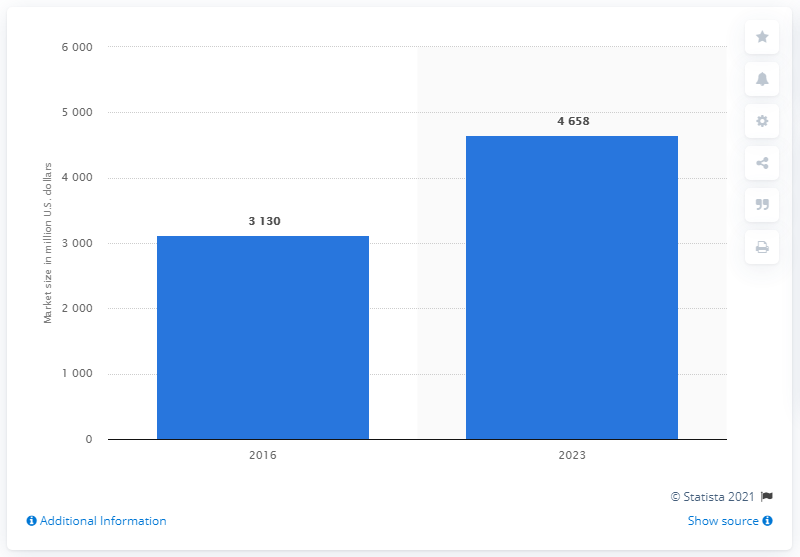Could you provide more context about the source of this data? The chart indicates that the source of the data is Statista, a company specializing in market and consumer data. The footnote '© Statista 2021' suggests that the information was published or compiled in that year. 